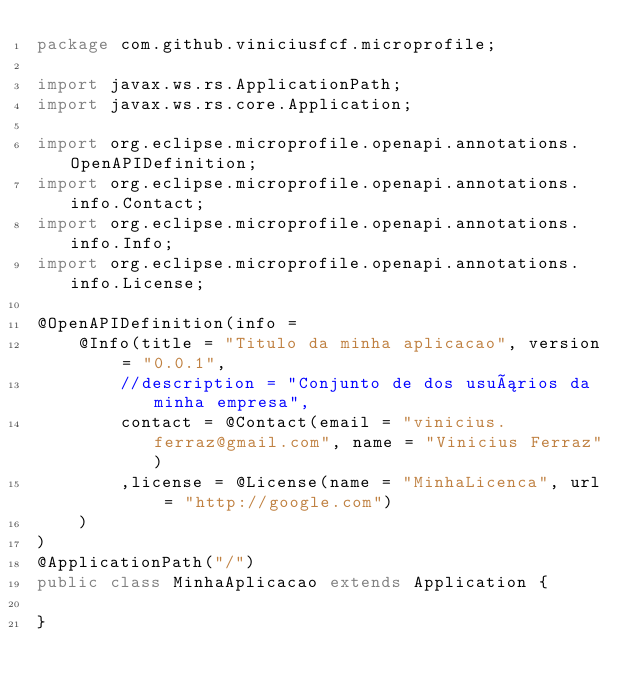<code> <loc_0><loc_0><loc_500><loc_500><_Java_>package com.github.viniciusfcf.microprofile;

import javax.ws.rs.ApplicationPath;
import javax.ws.rs.core.Application;

import org.eclipse.microprofile.openapi.annotations.OpenAPIDefinition;
import org.eclipse.microprofile.openapi.annotations.info.Contact;
import org.eclipse.microprofile.openapi.annotations.info.Info;
import org.eclipse.microprofile.openapi.annotations.info.License;

@OpenAPIDefinition(info = 
    @Info(title = "Titulo da minha aplicacao", version = "0.0.1",
        //description = "Conjunto de dos usuários da minha empresa",
        contact = @Contact(email = "vinicius.ferraz@gmail.com", name = "Vinicius Ferraz")
        ,license = @License(name = "MinhaLicenca", url = "http://google.com")
    )
)
@ApplicationPath("/")
public class MinhaAplicacao extends Application {
    
}</code> 